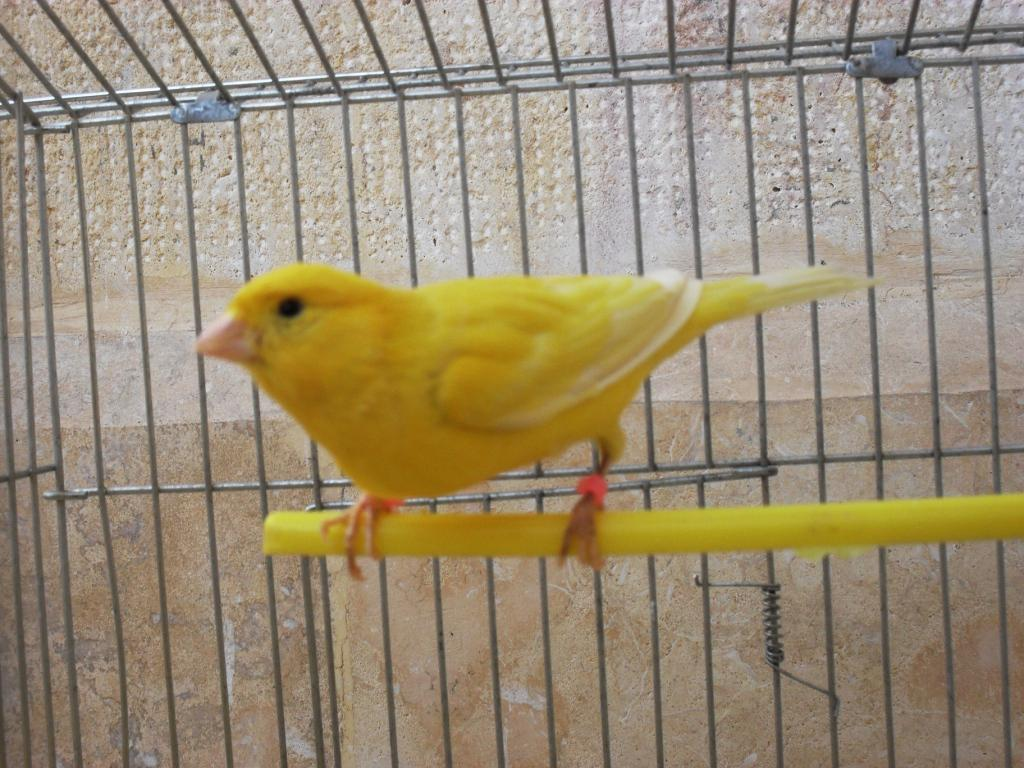What type of bird is in the image? There is a yellow love bird in the image. What is the love bird sitting on? The love bird is sitting on yellow sticks. What can be seen in the background of the image? There is a steel cage in the background of the image. What color is the wall behind the love bird? The background wall is white. What type of ray is swimming in the image? There is no ray present in the image; it features a yellow love bird sitting on yellow sticks. What channel is the love bird watching in the image? There is no television or channel present in the image. 